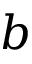Convert formula to latex. <formula><loc_0><loc_0><loc_500><loc_500>b</formula> 